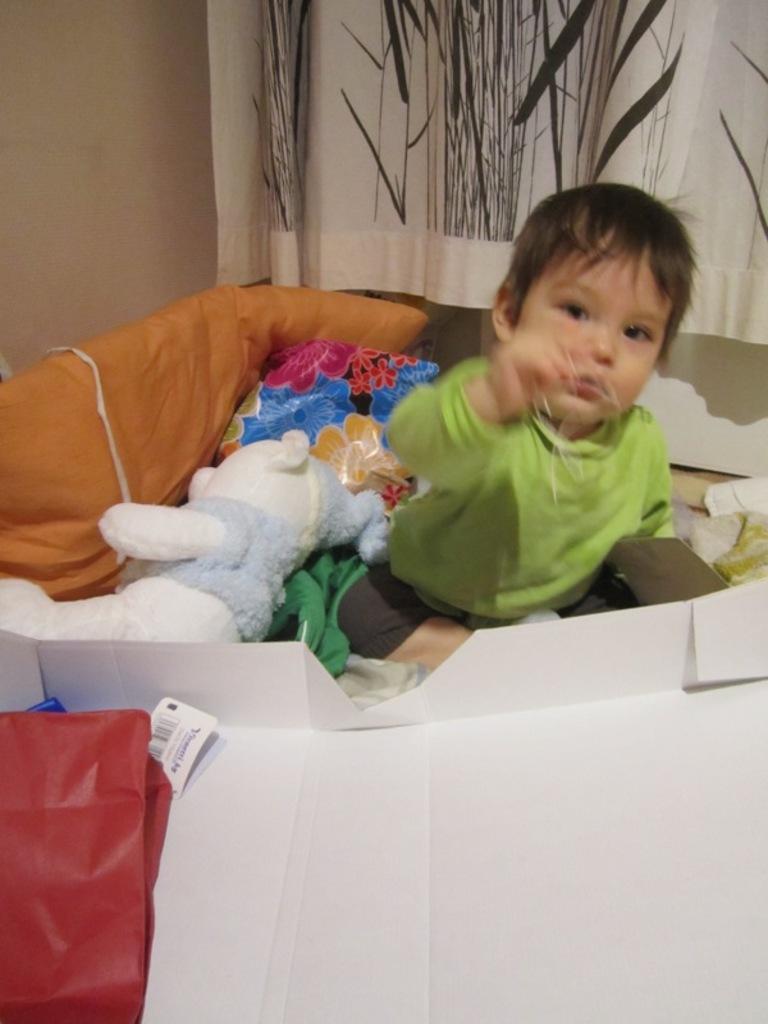Describe this image in one or two sentences. In this image there is a kid sitting. Beside him there is a toy, pillows, paper and few objects. Right side there is a curtain. Background there is a wall. 